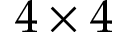Convert formula to latex. <formula><loc_0><loc_0><loc_500><loc_500>4 \times 4</formula> 